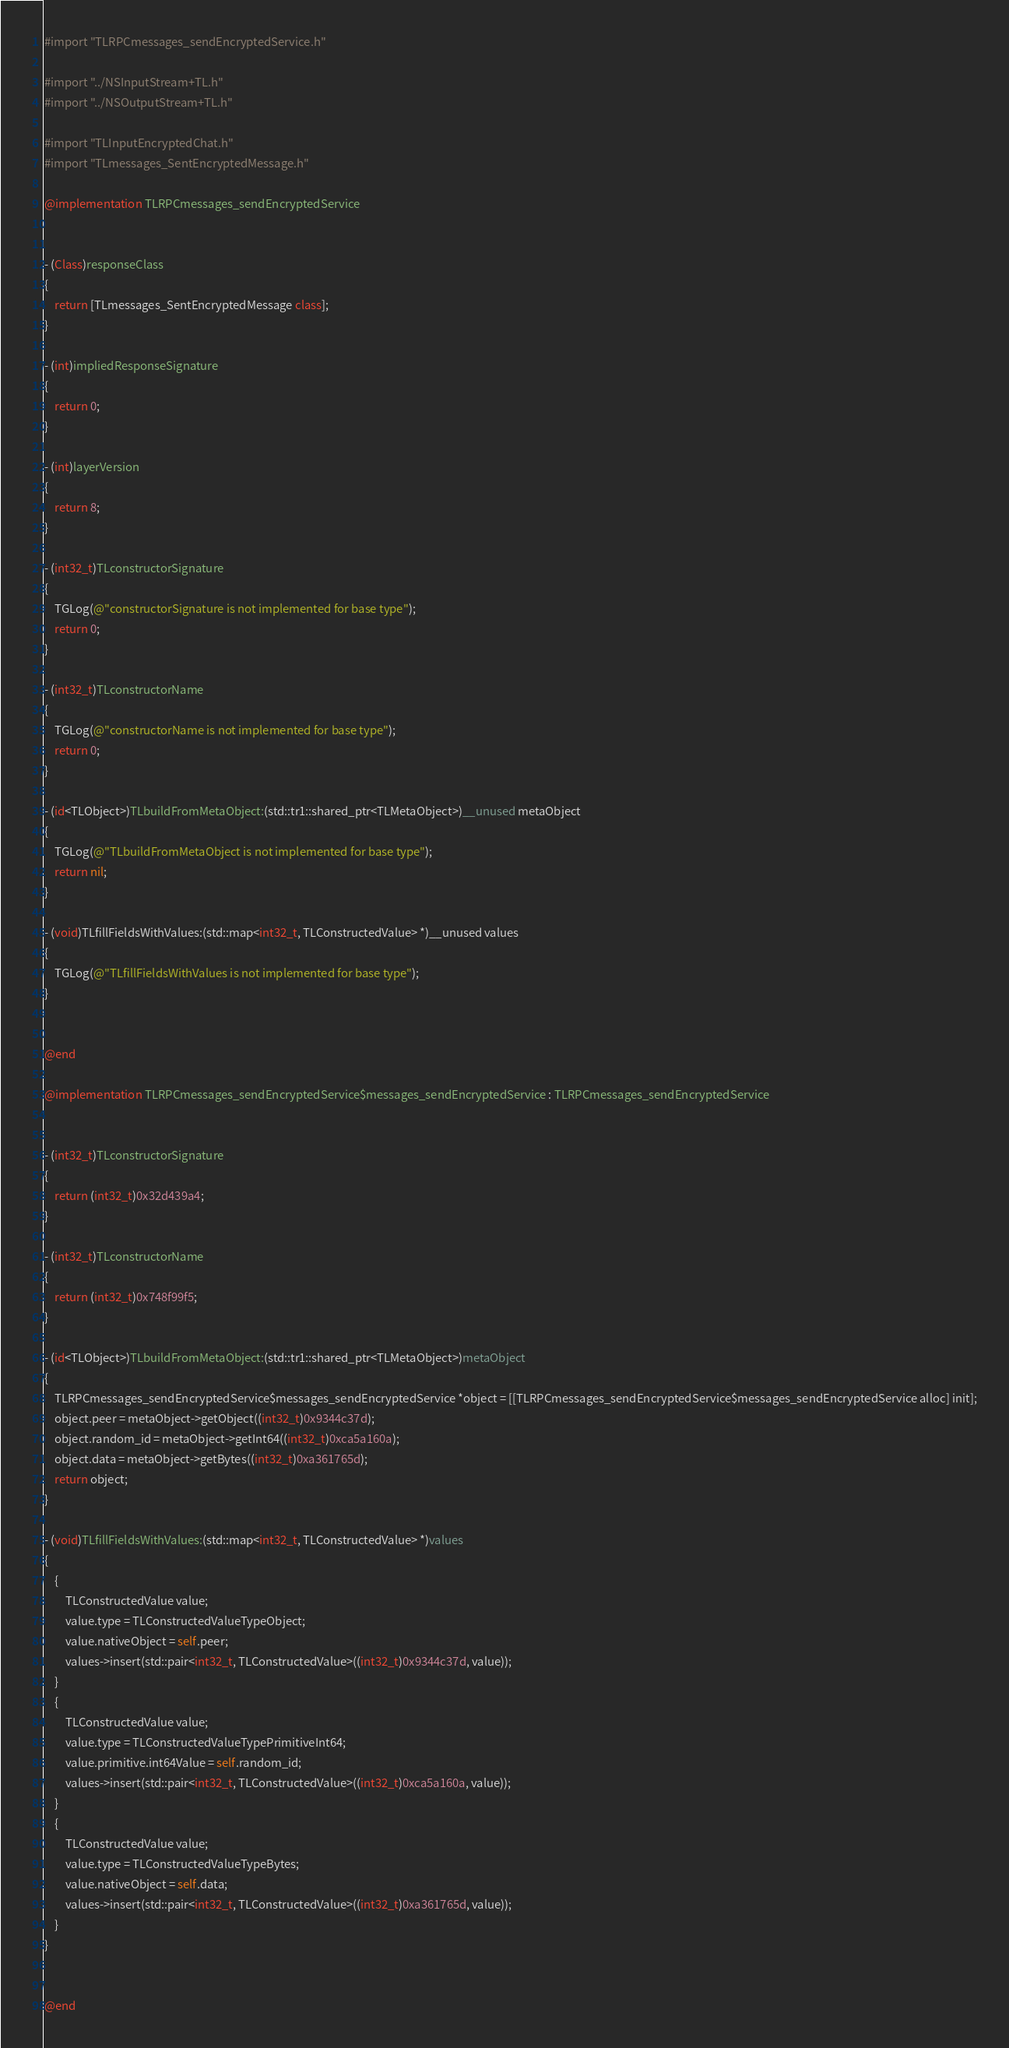<code> <loc_0><loc_0><loc_500><loc_500><_ObjectiveC_>#import "TLRPCmessages_sendEncryptedService.h"

#import "../NSInputStream+TL.h"
#import "../NSOutputStream+TL.h"

#import "TLInputEncryptedChat.h"
#import "TLmessages_SentEncryptedMessage.h"

@implementation TLRPCmessages_sendEncryptedService


- (Class)responseClass
{
    return [TLmessages_SentEncryptedMessage class];
}

- (int)impliedResponseSignature
{
    return 0;
}

- (int)layerVersion
{
    return 8;
}

- (int32_t)TLconstructorSignature
{
    TGLog(@"constructorSignature is not implemented for base type");
    return 0;
}

- (int32_t)TLconstructorName
{
    TGLog(@"constructorName is not implemented for base type");
    return 0;
}

- (id<TLObject>)TLbuildFromMetaObject:(std::tr1::shared_ptr<TLMetaObject>)__unused metaObject
{
    TGLog(@"TLbuildFromMetaObject is not implemented for base type");
    return nil;
}

- (void)TLfillFieldsWithValues:(std::map<int32_t, TLConstructedValue> *)__unused values
{
    TGLog(@"TLfillFieldsWithValues is not implemented for base type");
}


@end

@implementation TLRPCmessages_sendEncryptedService$messages_sendEncryptedService : TLRPCmessages_sendEncryptedService


- (int32_t)TLconstructorSignature
{
    return (int32_t)0x32d439a4;
}

- (int32_t)TLconstructorName
{
    return (int32_t)0x748f99f5;
}

- (id<TLObject>)TLbuildFromMetaObject:(std::tr1::shared_ptr<TLMetaObject>)metaObject
{
    TLRPCmessages_sendEncryptedService$messages_sendEncryptedService *object = [[TLRPCmessages_sendEncryptedService$messages_sendEncryptedService alloc] init];
    object.peer = metaObject->getObject((int32_t)0x9344c37d);
    object.random_id = metaObject->getInt64((int32_t)0xca5a160a);
    object.data = metaObject->getBytes((int32_t)0xa361765d);
    return object;
}

- (void)TLfillFieldsWithValues:(std::map<int32_t, TLConstructedValue> *)values
{
    {
        TLConstructedValue value;
        value.type = TLConstructedValueTypeObject;
        value.nativeObject = self.peer;
        values->insert(std::pair<int32_t, TLConstructedValue>((int32_t)0x9344c37d, value));
    }
    {
        TLConstructedValue value;
        value.type = TLConstructedValueTypePrimitiveInt64;
        value.primitive.int64Value = self.random_id;
        values->insert(std::pair<int32_t, TLConstructedValue>((int32_t)0xca5a160a, value));
    }
    {
        TLConstructedValue value;
        value.type = TLConstructedValueTypeBytes;
        value.nativeObject = self.data;
        values->insert(std::pair<int32_t, TLConstructedValue>((int32_t)0xa361765d, value));
    }
}


@end

</code> 